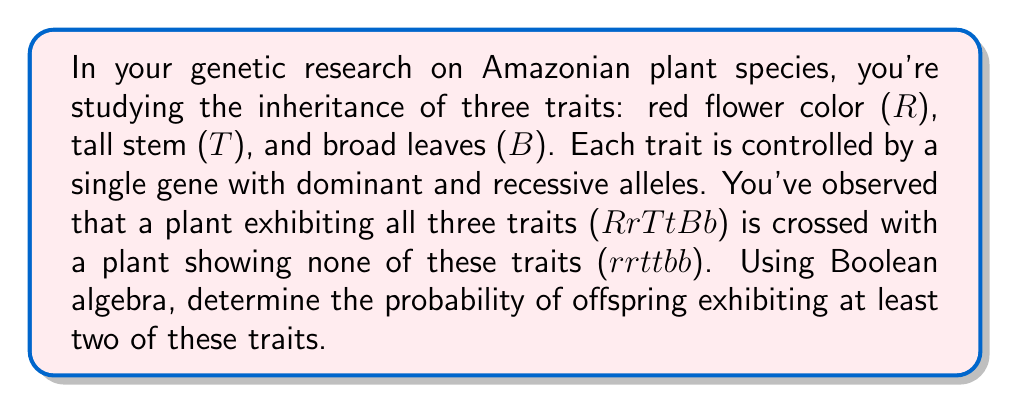Give your solution to this math problem. Let's approach this step-by-step using Boolean algebra:

1) First, we need to define our variables:
   R: red flower color
   T: tall stem
   B: broad leaves

2) The probability of each trait being expressed in the offspring is 1/2, as the parent with the dominant allele is heterozygous for each trait.

3) We can express the probability of each trait as:
   P(R) = P(T) = P(B) = 1/2

4) The probability of not having each trait is the complement:
   P(r) = P(t) = P(b) = 1 - 1/2 = 1/2

5) We want the probability of at least two traits, which is equivalent to the complement of having one or no traits. In Boolean terms:

   P(at least two traits) = 1 - P(one or no traits)

6) The probability of one or no traits can be expressed as:
   P(RTb + RtB + rTB + rtb)

7) Using the distributive property of Boolean algebra:
   P(RTb + RtB + rTB + rtb) = P(RT)P(b) + P(R)P(t)P(B) + P(r)P(T)P(B) + P(r)P(t)P(b)

8) Substituting the probabilities:
   (1/2 * 1/2 * 1/2) + (1/2 * 1/2 * 1/2) + (1/2 * 1/2 * 1/2) + (1/2 * 1/2 * 1/2)
   = 4 * (1/8) = 1/2

9) Therefore, the probability of at least two traits is:
   1 - 1/2 = 1/2

Thus, the probability of offspring exhibiting at least two of these traits is 1/2 or 50%.
Answer: 1/2 